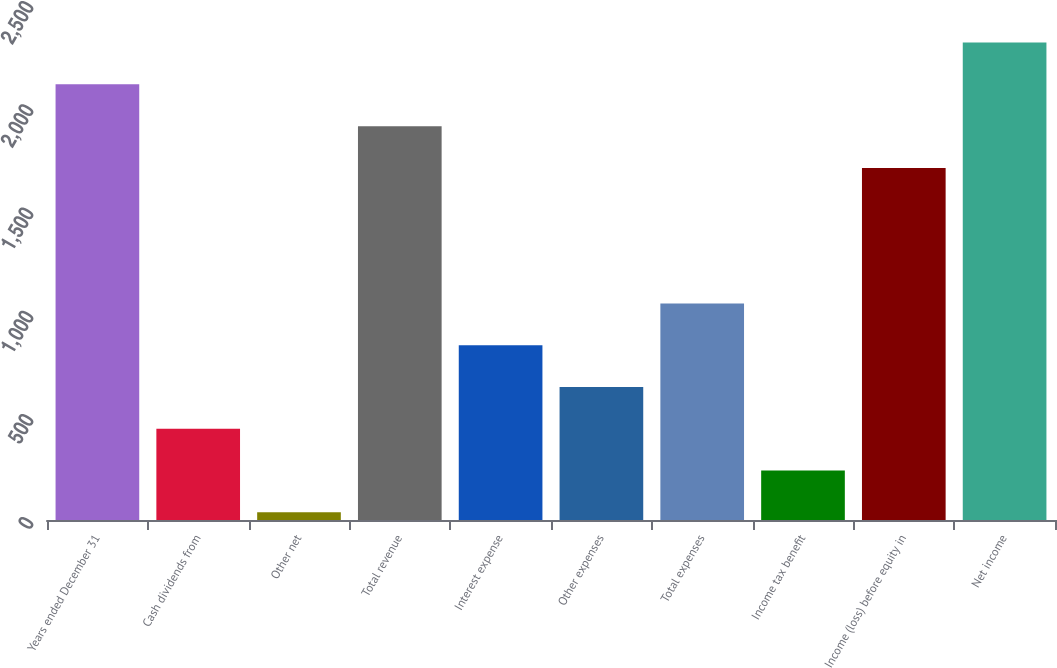<chart> <loc_0><loc_0><loc_500><loc_500><bar_chart><fcel>Years ended December 31<fcel>Cash dividends from<fcel>Other net<fcel>Total revenue<fcel>Interest expense<fcel>Other expenses<fcel>Total expenses<fcel>Income tax benefit<fcel>Income (loss) before equity in<fcel>Net income<nl><fcel>2110.6<fcel>442.6<fcel>38<fcel>1908.3<fcel>847.2<fcel>644.9<fcel>1049.5<fcel>240.3<fcel>1706<fcel>2312.9<nl></chart> 